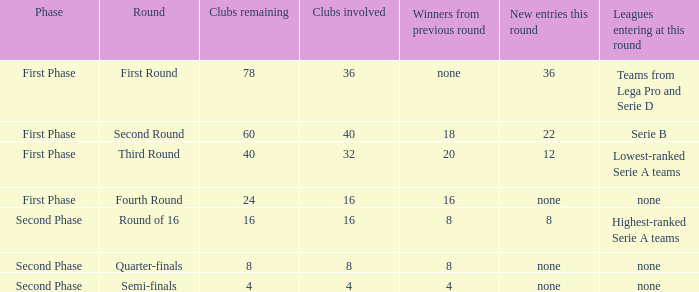When looking at new entries this round and seeing 8; what number in total is there for clubs remaining? 1.0. 